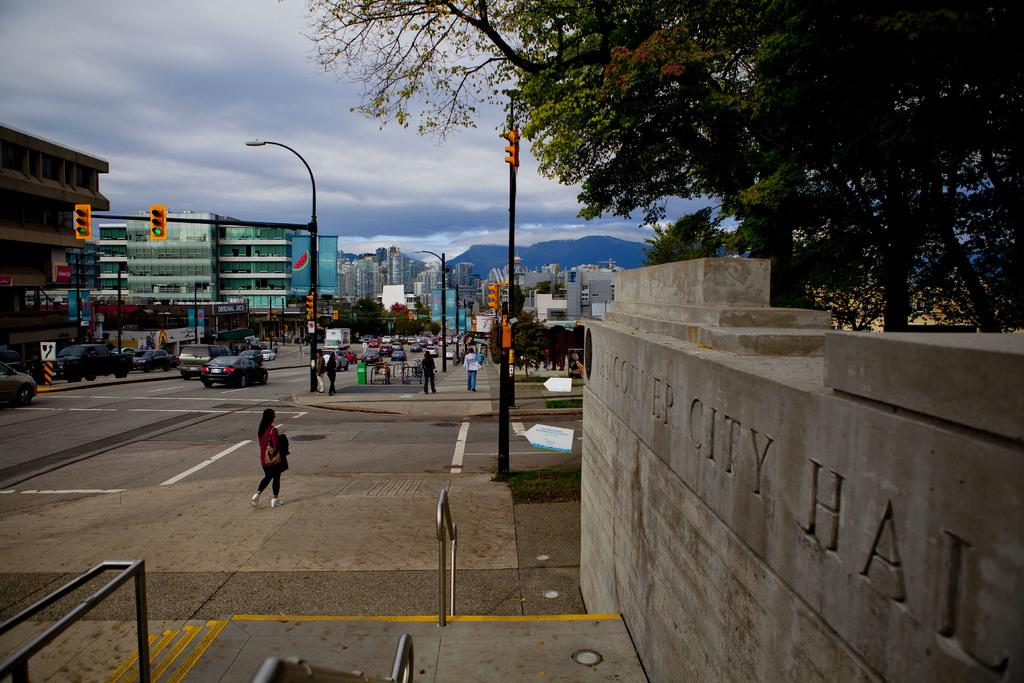What are the people in the image doing? The people in the image are walking on the street. What else can be seen on the road besides people? There are vehicles on the road. What type of structures are visible in the image? There are many buildings in the image. How do the vehicles and people navigate the road? There are traffic signals in the image to help with navigation. What type of vegetation is present in the image? There are trees in the image. What is the weather like in the image? The sky is cloudy in the image. How many visitors are present in the image? There is no mention of visitors in the image; it shows people walking on the street and vehicles on the road. What type of attraction can be seen in the image? There is no attraction present in the image; it shows a street with buildings, trees, and traffic signals. 